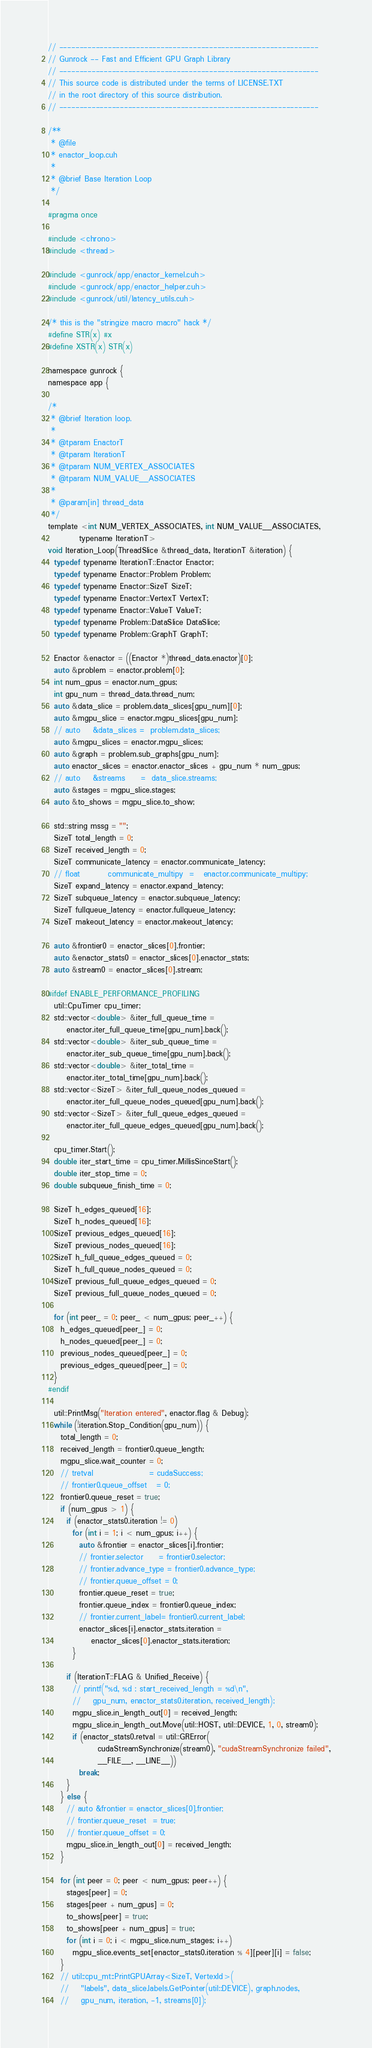<code> <loc_0><loc_0><loc_500><loc_500><_Cuda_>// ----------------------------------------------------------------
// Gunrock -- Fast and Efficient GPU Graph Library
// ----------------------------------------------------------------
// This source code is distributed under the terms of LICENSE.TXT
// in the root directory of this source distribution.
// ----------------------------------------------------------------

/**
 * @file
 * enactor_loop.cuh
 *
 * @brief Base Iteration Loop
 */

#pragma once

#include <chrono>
#include <thread>

#include <gunrock/app/enactor_kernel.cuh>
#include <gunrock/app/enactor_helper.cuh>
#include <gunrock/util/latency_utils.cuh>

/* this is the "stringize macro macro" hack */
#define STR(x) #x
#define XSTR(x) STR(x)

namespace gunrock {
namespace app {

/*
 * @brief Iteration loop.
 *
 * @tparam EnactorT
 * @tparam IterationT
 * @tparam NUM_VERTEX_ASSOCIATES
 * @tparam NUM_VALUE__ASSOCIATES
 *
 * @param[in] thread_data
 */
template <int NUM_VERTEX_ASSOCIATES, int NUM_VALUE__ASSOCIATES,
          typename IterationT>
void Iteration_Loop(ThreadSlice &thread_data, IterationT &iteration) {
  typedef typename IterationT::Enactor Enactor;
  typedef typename Enactor::Problem Problem;
  typedef typename Enactor::SizeT SizeT;
  typedef typename Enactor::VertexT VertexT;
  typedef typename Enactor::ValueT ValueT;
  typedef typename Problem::DataSlice DataSlice;
  typedef typename Problem::GraphT GraphT;

  Enactor &enactor = ((Enactor *)thread_data.enactor)[0];
  auto &problem = enactor.problem[0];
  int num_gpus = enactor.num_gpus;
  int gpu_num = thread_data.thread_num;
  auto &data_slice = problem.data_slices[gpu_num][0];
  auto &mgpu_slice = enactor.mgpu_slices[gpu_num];
  // auto    &data_slices =  problem.data_slices;
  auto &mgpu_slices = enactor.mgpu_slices;
  auto &graph = problem.sub_graphs[gpu_num];
  auto enactor_slices = enactor.enactor_slices + gpu_num * num_gpus;
  // auto    &streams     =  data_slice.streams;
  auto &stages = mgpu_slice.stages;
  auto &to_shows = mgpu_slice.to_show;

  std::string mssg = "";
  SizeT total_length = 0;
  SizeT received_length = 0;
  SizeT communicate_latency = enactor.communicate_latency;
  // float         communicate_multipy  =   enactor.communicate_multipy;
  SizeT expand_latency = enactor.expand_latency;
  SizeT subqueue_latency = enactor.subqueue_latency;
  SizeT fullqueue_latency = enactor.fullqueue_latency;
  SizeT makeout_latency = enactor.makeout_latency;

  auto &frontier0 = enactor_slices[0].frontier;
  auto &enactor_stats0 = enactor_slices[0].enactor_stats;
  auto &stream0 = enactor_slices[0].stream;

#ifdef ENABLE_PERFORMANCE_PROFILING
  util::CpuTimer cpu_timer;
  std::vector<double> &iter_full_queue_time =
      enactor.iter_full_queue_time[gpu_num].back();
  std::vector<double> &iter_sub_queue_time =
      enactor.iter_sub_queue_time[gpu_num].back();
  std::vector<double> &iter_total_time =
      enactor.iter_total_time[gpu_num].back();
  std::vector<SizeT> &iter_full_queue_nodes_queued =
      enactor.iter_full_queue_nodes_queued[gpu_num].back();
  std::vector<SizeT> &iter_full_queue_edges_queued =
      enactor.iter_full_queue_edges_queued[gpu_num].back();

  cpu_timer.Start();
  double iter_start_time = cpu_timer.MillisSinceStart();
  double iter_stop_time = 0;
  double subqueue_finish_time = 0;

  SizeT h_edges_queued[16];
  SizeT h_nodes_queued[16];
  SizeT previous_edges_queued[16];
  SizeT previous_nodes_queued[16];
  SizeT h_full_queue_edges_queued = 0;
  SizeT h_full_queue_nodes_queued = 0;
  SizeT previous_full_queue_edges_queued = 0;
  SizeT previous_full_queue_nodes_queued = 0;

  for (int peer_ = 0; peer_ < num_gpus; peer_++) {
    h_edges_queued[peer_] = 0;
    h_nodes_queued[peer_] = 0;
    previous_nodes_queued[peer_] = 0;
    previous_edges_queued[peer_] = 0;
  }
#endif

  util::PrintMsg("Iteration entered", enactor.flag & Debug);
  while (!iteration.Stop_Condition(gpu_num)) {
    total_length = 0;
    received_length = frontier0.queue_length;
    mgpu_slice.wait_counter = 0;
    // tretval                  = cudaSuccess;
    // frontier0.queue_offset   = 0;
    frontier0.queue_reset = true;
    if (num_gpus > 1) {
      if (enactor_stats0.iteration != 0)
        for (int i = 1; i < num_gpus; i++) {
          auto &frontier = enactor_slices[i].frontier;
          // frontier.selector     = frontier0.selector;
          // frontier.advance_type = frontier0.advance_type;
          // frontier.queue_offset = 0;
          frontier.queue_reset = true;
          frontier.queue_index = frontier0.queue_index;
          // frontier.current_label= frontier0.current_label;
          enactor_slices[i].enactor_stats.iteration =
              enactor_slices[0].enactor_stats.iteration;
        }

      if (IterationT::FLAG & Unified_Receive) {
        // printf("%d, %d : start_received_length = %d\n",
        //    gpu_num, enactor_stats0.iteration, received_length);
        mgpu_slice.in_length_out[0] = received_length;
        mgpu_slice.in_length_out.Move(util::HOST, util::DEVICE, 1, 0, stream0);
        if (enactor_stats0.retval = util::GRError(
                cudaStreamSynchronize(stream0), "cudaStreamSynchronize failed",
                __FILE__, __LINE__))
          break;
      }
    } else {
      // auto &frontier = enactor_slices[0].frontier;
      // frontier.queue_reset  = true;
      // frontier.queue_offset = 0;
      mgpu_slice.in_length_out[0] = received_length;
    }

    for (int peer = 0; peer < num_gpus; peer++) {
      stages[peer] = 0;
      stages[peer + num_gpus] = 0;
      to_shows[peer] = true;
      to_shows[peer + num_gpus] = true;
      for (int i = 0; i < mgpu_slice.num_stages; i++)
        mgpu_slice.events_set[enactor_stats0.iteration % 4][peer][i] = false;
    }
    // util::cpu_mt::PrintGPUArray<SizeT, VertexId>(
    //    "labels", data_slice.labels.GetPointer(util::DEVICE), graph.nodes,
    //    gpu_num, iteration, -1, streams[0]);
</code> 